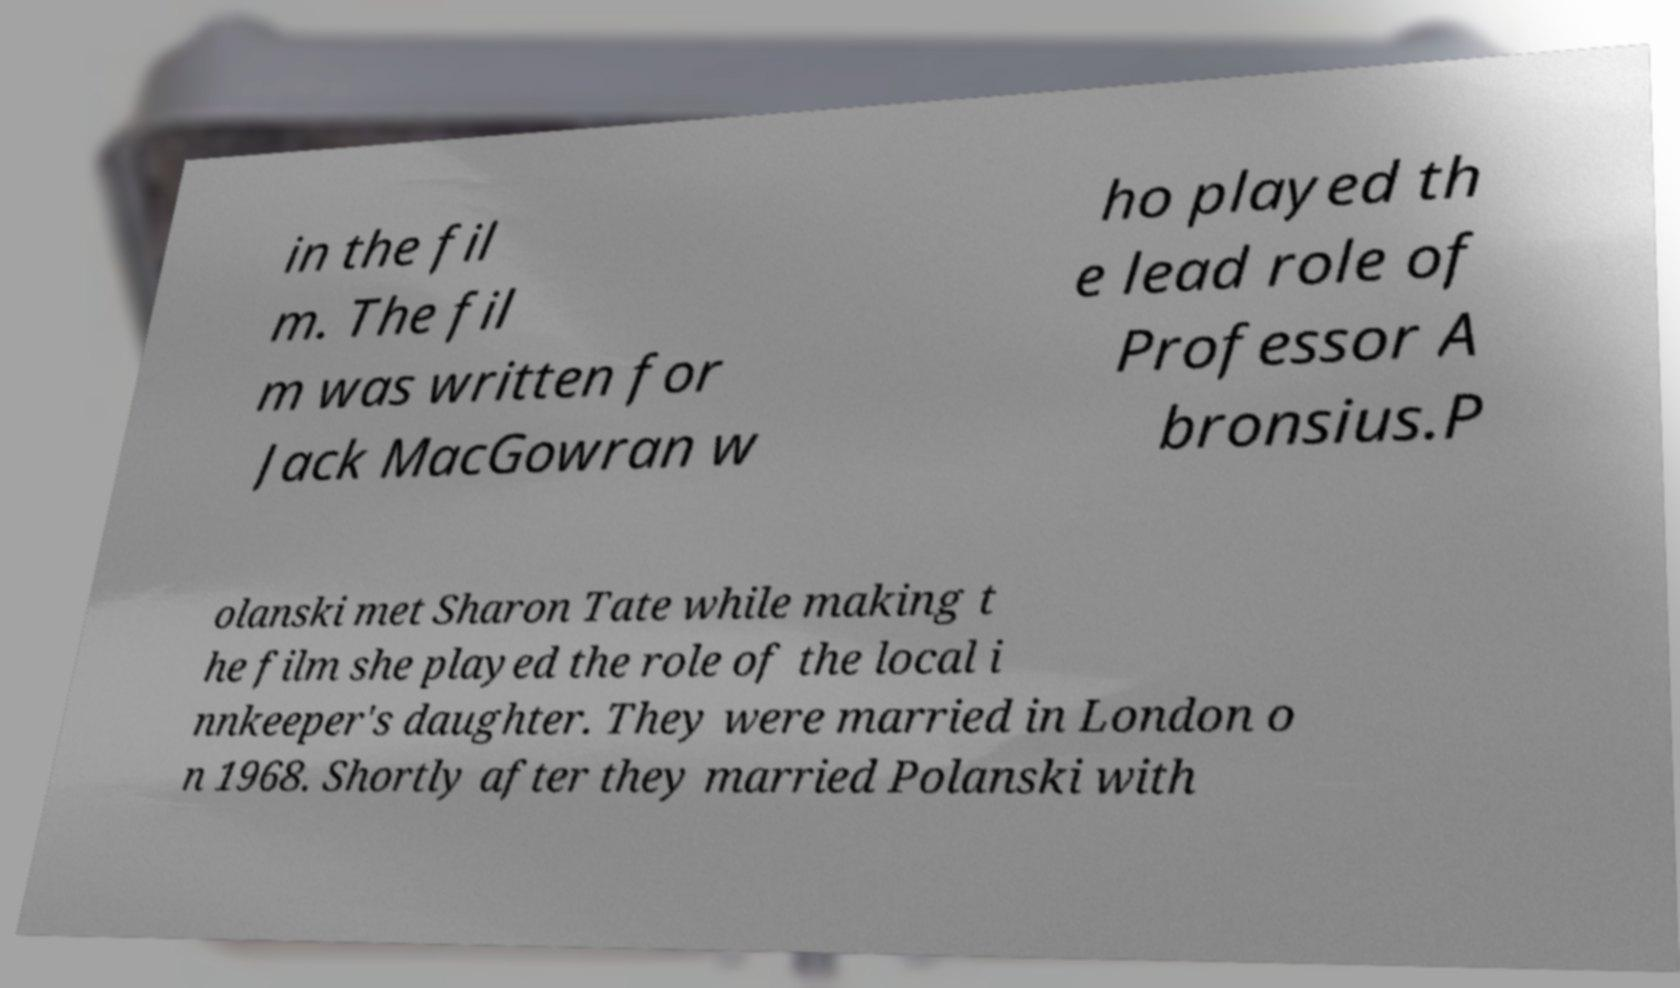Can you accurately transcribe the text from the provided image for me? in the fil m. The fil m was written for Jack MacGowran w ho played th e lead role of Professor A bronsius.P olanski met Sharon Tate while making t he film she played the role of the local i nnkeeper's daughter. They were married in London o n 1968. Shortly after they married Polanski with 